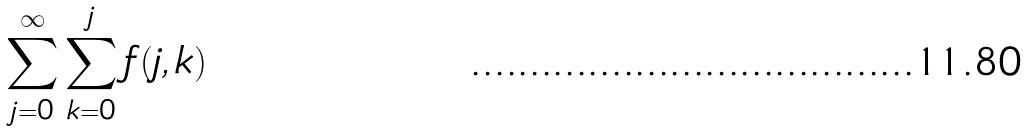<formula> <loc_0><loc_0><loc_500><loc_500>\sum _ { j = 0 } ^ { \infty } \sum _ { k = 0 } ^ { j } f ( j , k )</formula> 